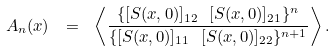<formula> <loc_0><loc_0><loc_500><loc_500>A _ { n } ( x ) \ = \ \left \langle \frac { \{ [ S ( x , 0 ) ] _ { 1 2 } \ [ S ( x , 0 ) ] _ { 2 1 } \} ^ { n } } { \{ [ S ( x , 0 ) ] _ { 1 1 } \ [ S ( x , 0 ) ] _ { 2 2 } \} ^ { n + 1 } } \right \rangle .</formula> 